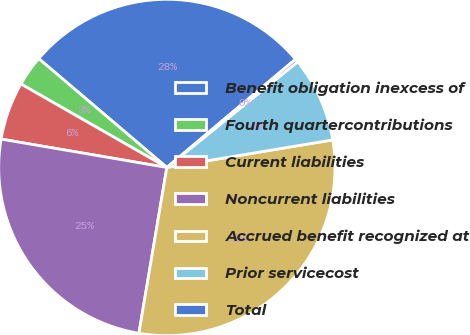Convert chart to OTSL. <chart><loc_0><loc_0><loc_500><loc_500><pie_chart><fcel>Benefit obligation inexcess of<fcel>Fourth quartercontributions<fcel>Current liabilities<fcel>Noncurrent liabilities<fcel>Accrued benefit recognized at<fcel>Prior servicecost<fcel>Total<nl><fcel>27.66%<fcel>2.94%<fcel>5.57%<fcel>25.04%<fcel>30.28%<fcel>8.19%<fcel>0.32%<nl></chart> 